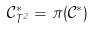Convert formula to latex. <formula><loc_0><loc_0><loc_500><loc_500>\mathcal { C } ^ { * } _ { T ^ { 2 } } = \pi ( \mathcal { C } ^ { * } )</formula> 